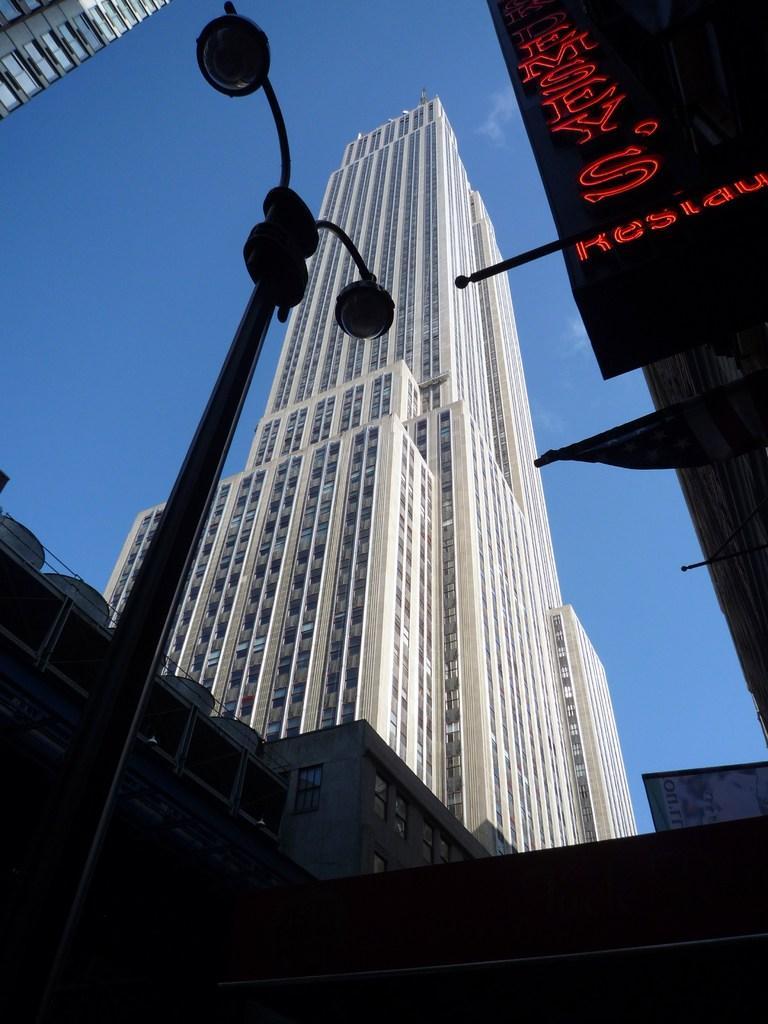Please provide a concise description of this image. In this image there are a few buildings and there is a banner with some text hanging from one of the buildings, there are two lights to a pole and the sky. 